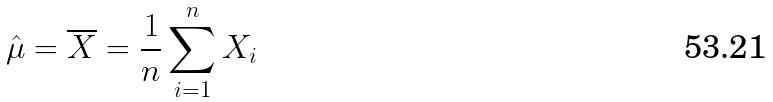Convert formula to latex. <formula><loc_0><loc_0><loc_500><loc_500>\hat { \mu } = \overline { X } = \frac { 1 } { n } \sum _ { i = 1 } ^ { n } X _ { i }</formula> 